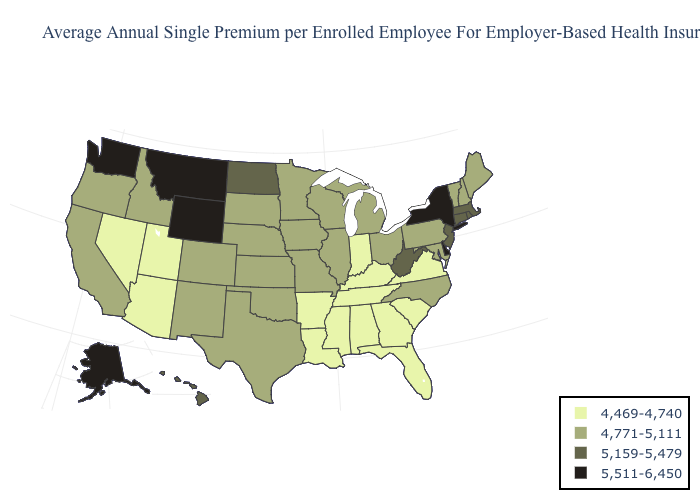Does Delaware have the highest value in the USA?
Keep it brief. Yes. Name the states that have a value in the range 5,511-6,450?
Answer briefly. Alaska, Delaware, Montana, New York, Washington, Wyoming. What is the lowest value in the South?
Answer briefly. 4,469-4,740. What is the value of Hawaii?
Give a very brief answer. 5,159-5,479. Name the states that have a value in the range 4,771-5,111?
Keep it brief. California, Colorado, Idaho, Illinois, Iowa, Kansas, Maine, Maryland, Michigan, Minnesota, Missouri, Nebraska, New Hampshire, New Mexico, North Carolina, Ohio, Oklahoma, Oregon, Pennsylvania, South Dakota, Texas, Vermont, Wisconsin. Name the states that have a value in the range 4,469-4,740?
Keep it brief. Alabama, Arizona, Arkansas, Florida, Georgia, Indiana, Kentucky, Louisiana, Mississippi, Nevada, South Carolina, Tennessee, Utah, Virginia. Which states have the lowest value in the Northeast?
Quick response, please. Maine, New Hampshire, Pennsylvania, Vermont. Does Nevada have the lowest value in the West?
Write a very short answer. Yes. Name the states that have a value in the range 4,469-4,740?
Keep it brief. Alabama, Arizona, Arkansas, Florida, Georgia, Indiana, Kentucky, Louisiana, Mississippi, Nevada, South Carolina, Tennessee, Utah, Virginia. Name the states that have a value in the range 4,469-4,740?
Answer briefly. Alabama, Arizona, Arkansas, Florida, Georgia, Indiana, Kentucky, Louisiana, Mississippi, Nevada, South Carolina, Tennessee, Utah, Virginia. What is the lowest value in the West?
Concise answer only. 4,469-4,740. Name the states that have a value in the range 5,511-6,450?
Write a very short answer. Alaska, Delaware, Montana, New York, Washington, Wyoming. What is the value of Washington?
Answer briefly. 5,511-6,450. What is the value of Texas?
Concise answer only. 4,771-5,111. 